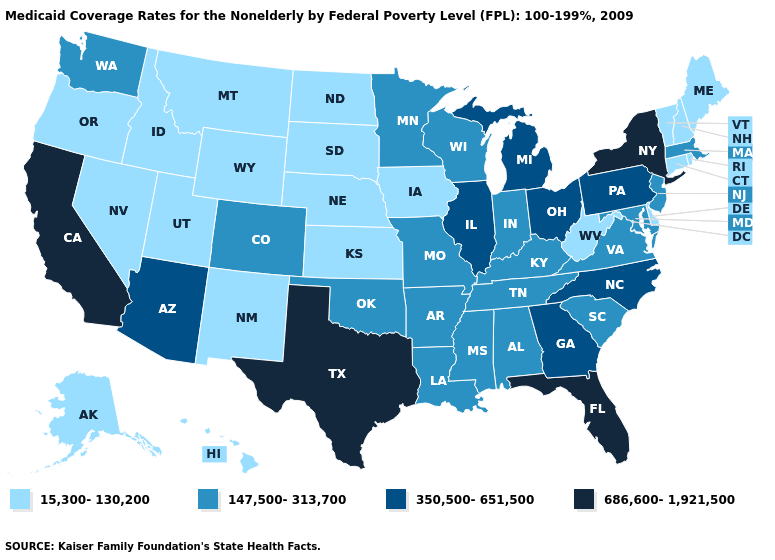Name the states that have a value in the range 15,300-130,200?
Write a very short answer. Alaska, Connecticut, Delaware, Hawaii, Idaho, Iowa, Kansas, Maine, Montana, Nebraska, Nevada, New Hampshire, New Mexico, North Dakota, Oregon, Rhode Island, South Dakota, Utah, Vermont, West Virginia, Wyoming. Does New Jersey have a higher value than West Virginia?
Be succinct. Yes. Name the states that have a value in the range 350,500-651,500?
Keep it brief. Arizona, Georgia, Illinois, Michigan, North Carolina, Ohio, Pennsylvania. What is the value of Massachusetts?
Short answer required. 147,500-313,700. Does Alabama have the highest value in the USA?
Quick response, please. No. What is the lowest value in the USA?
Keep it brief. 15,300-130,200. Does Rhode Island have the lowest value in the USA?
Concise answer only. Yes. Name the states that have a value in the range 147,500-313,700?
Short answer required. Alabama, Arkansas, Colorado, Indiana, Kentucky, Louisiana, Maryland, Massachusetts, Minnesota, Mississippi, Missouri, New Jersey, Oklahoma, South Carolina, Tennessee, Virginia, Washington, Wisconsin. Name the states that have a value in the range 15,300-130,200?
Keep it brief. Alaska, Connecticut, Delaware, Hawaii, Idaho, Iowa, Kansas, Maine, Montana, Nebraska, Nevada, New Hampshire, New Mexico, North Dakota, Oregon, Rhode Island, South Dakota, Utah, Vermont, West Virginia, Wyoming. Name the states that have a value in the range 15,300-130,200?
Give a very brief answer. Alaska, Connecticut, Delaware, Hawaii, Idaho, Iowa, Kansas, Maine, Montana, Nebraska, Nevada, New Hampshire, New Mexico, North Dakota, Oregon, Rhode Island, South Dakota, Utah, Vermont, West Virginia, Wyoming. What is the value of South Carolina?
Write a very short answer. 147,500-313,700. Among the states that border Pennsylvania , does Delaware have the lowest value?
Answer briefly. Yes. What is the value of Illinois?
Short answer required. 350,500-651,500. Does the map have missing data?
Answer briefly. No. 